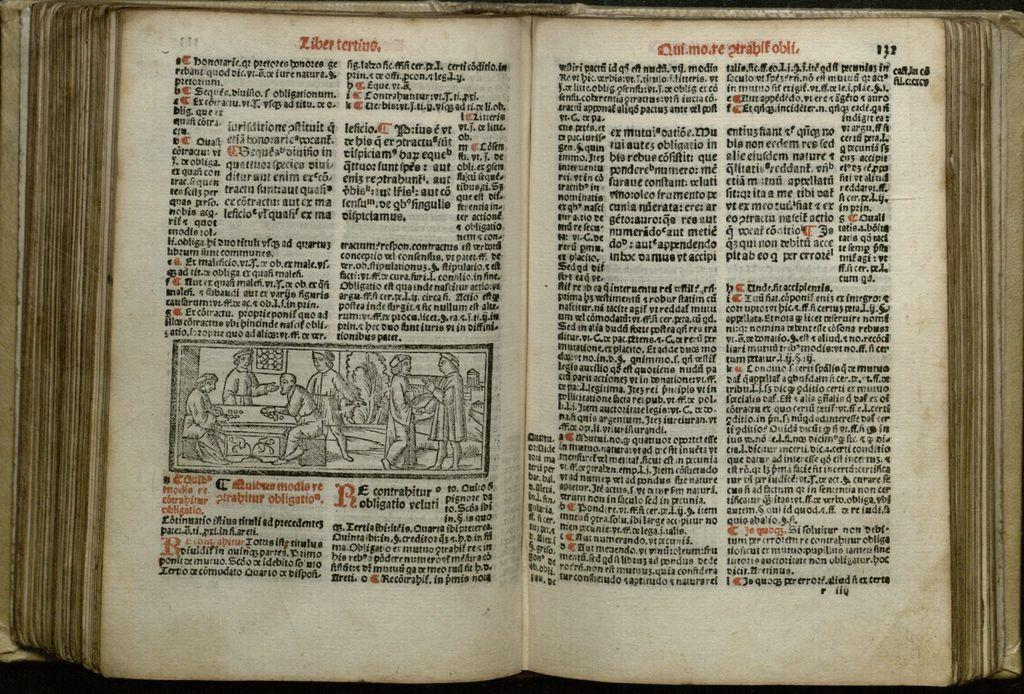<image>
Render a clear and concise summary of the photo. An open book showing pages 131 and 132. 